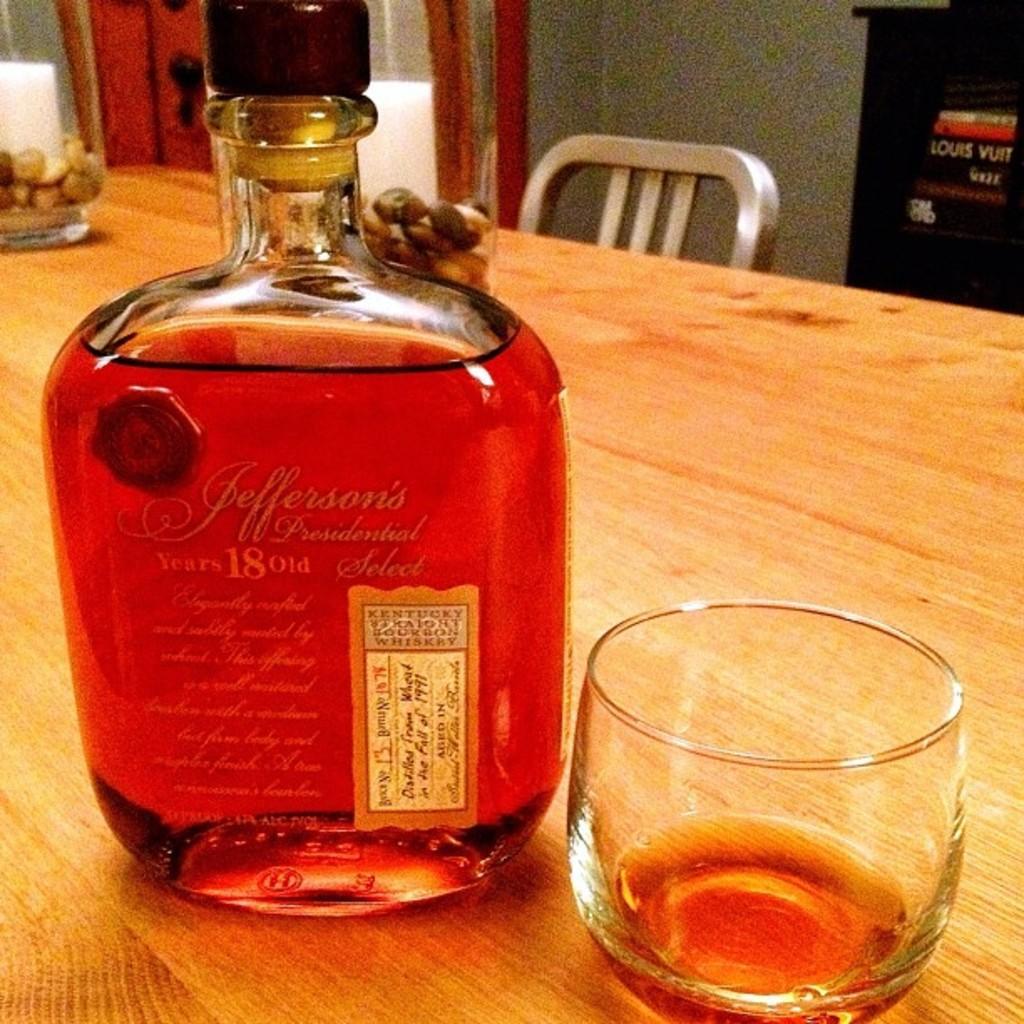In one or two sentences, can you explain what this image depicts? In this image, There is a table which is in yellow color on that table there is a wine bottle which contains wine in red color, There is a glass on the table, There is a chair which is in white color, In the background there is a gray color wall. 